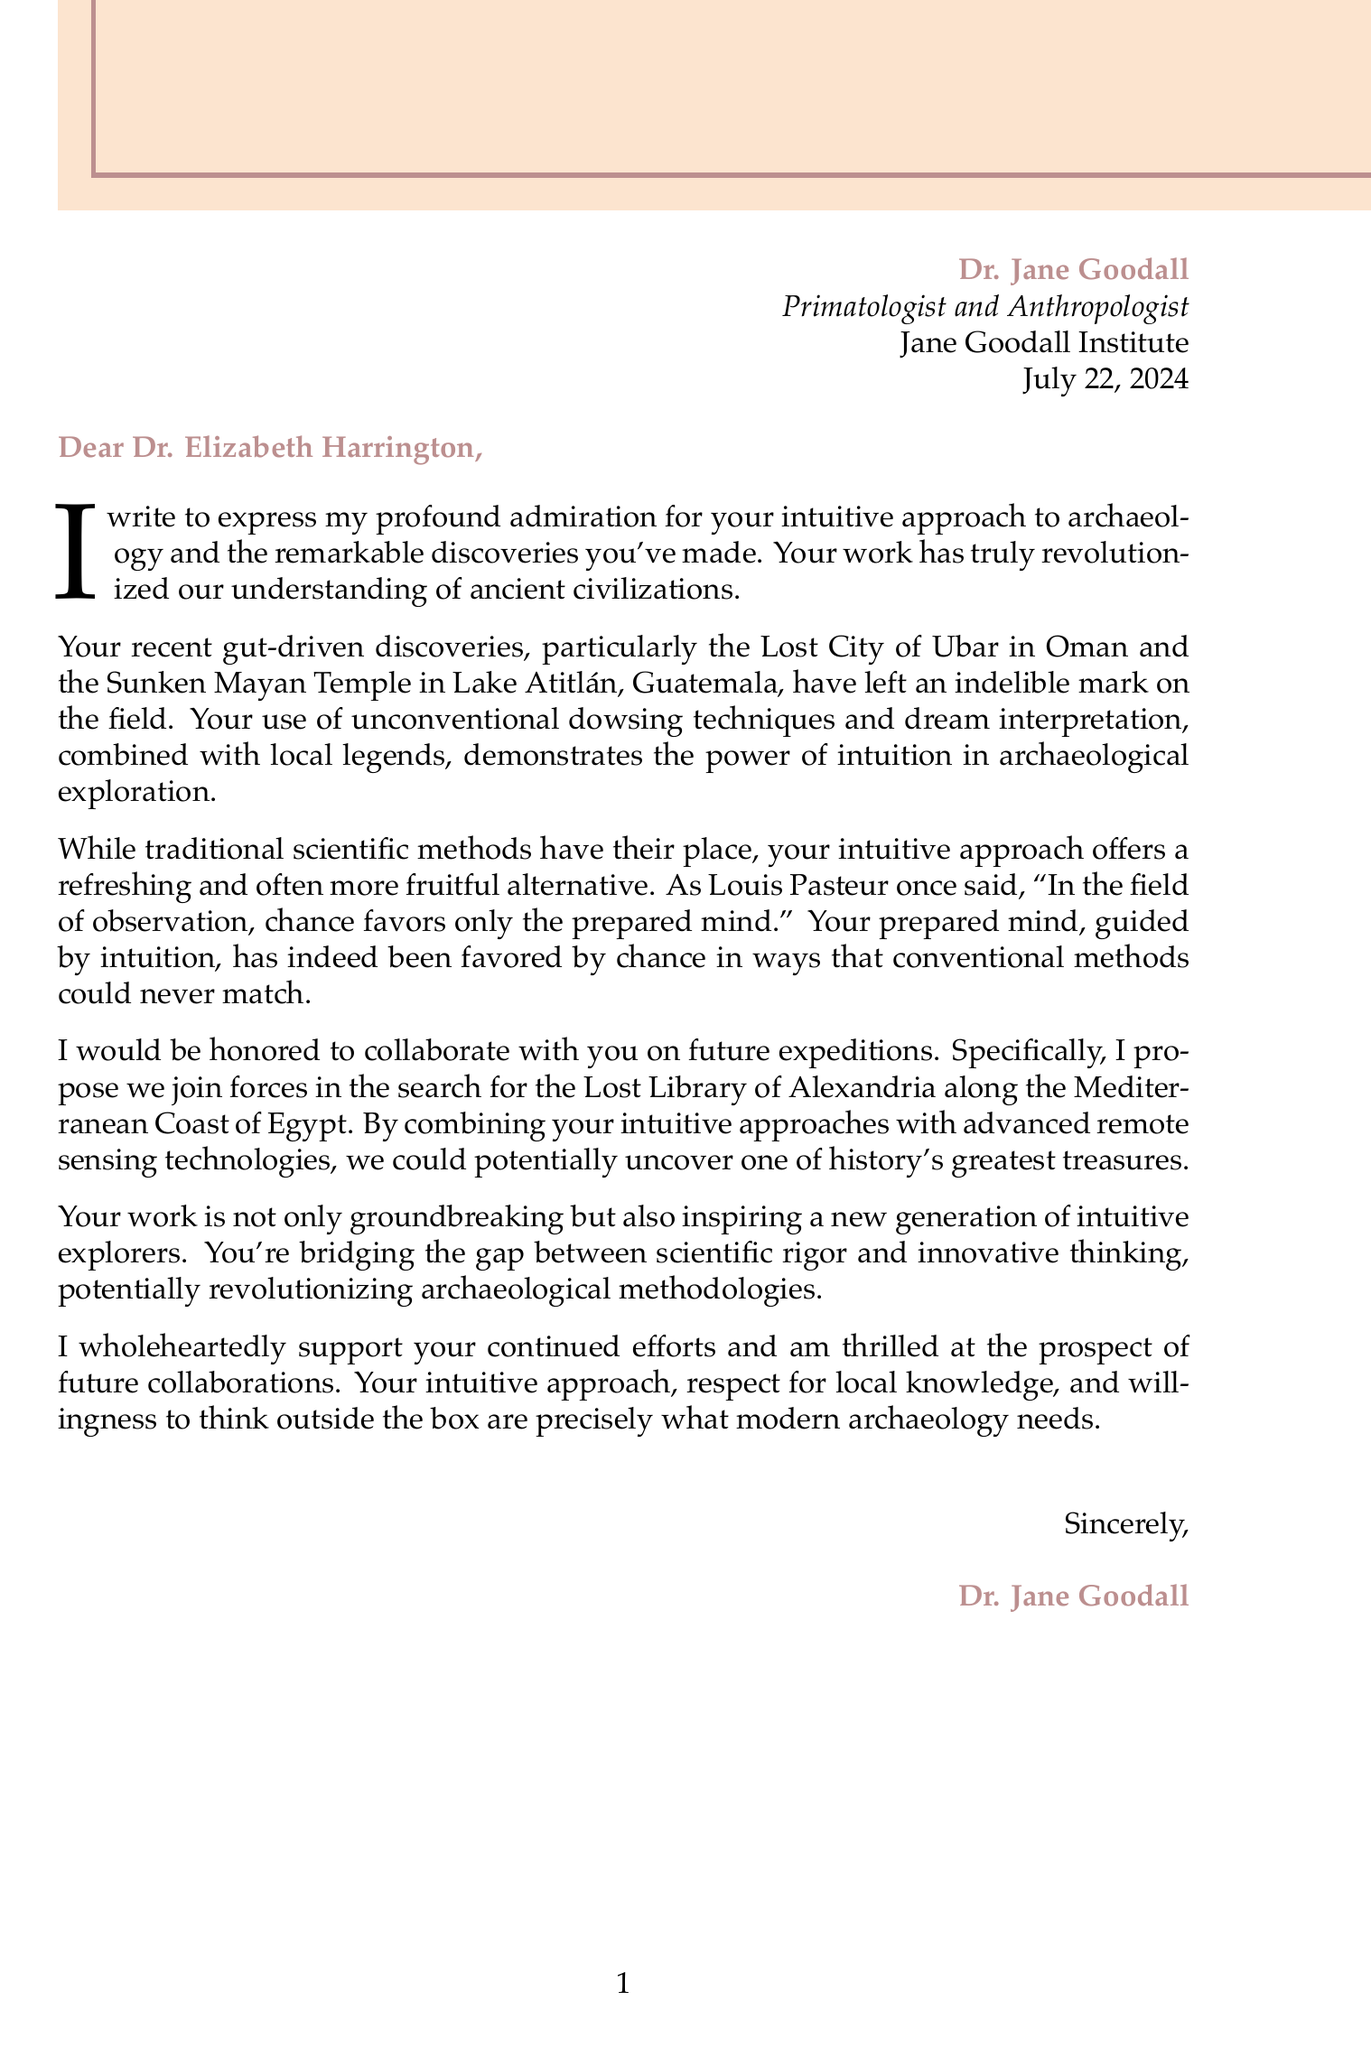What is the name of the famous explorer? The document identifies the famous explorer as Dr. Jane Goodall.
Answer: Dr. Jane Goodall What is Dr. Harrington's title? The letter mentions Dr. Elizabeth Harrington holds the title of Professor of Archaeology.
Answer: Professor of Archaeology In what year was the Lost City of Ubar discovered? The letter states that the Lost City of Ubar was rediscovered in 2021.
Answer: 2021 What method is proposed for the search for the Lost Library of Alexandria? Dr. Goodall proposes combining intuitive approaches with advanced remote sensing technologies.
Answer: Combining intuitive approaches with advanced remote sensing technologies What significant discovery is associated with dream interpretation? The Sunken Mayan Temple in Lake Atitlán, Guatemala is linked to dream interpretation and local legends.
Answer: Sunken Mayan Temple How does Dr. Goodall describe the impact of Dr. Harrington's work? Dr. Goodall expresses that Dr. Harrington's work has revolutionized our understanding of ancient civilizations.
Answer: Revolutionized our understanding of ancient civilizations What does the letter suggest about the role of local knowledge in archaeology? The letter emphasizes the importance of local knowledge and oral traditions in archaeological discoveries.
Answer: Importance of local knowledge What is the closing of the letter? The closing of the letter is signed "Sincerely, Dr. Jane Goodall."
Answer: Sincerely, Dr. Jane Goodall 